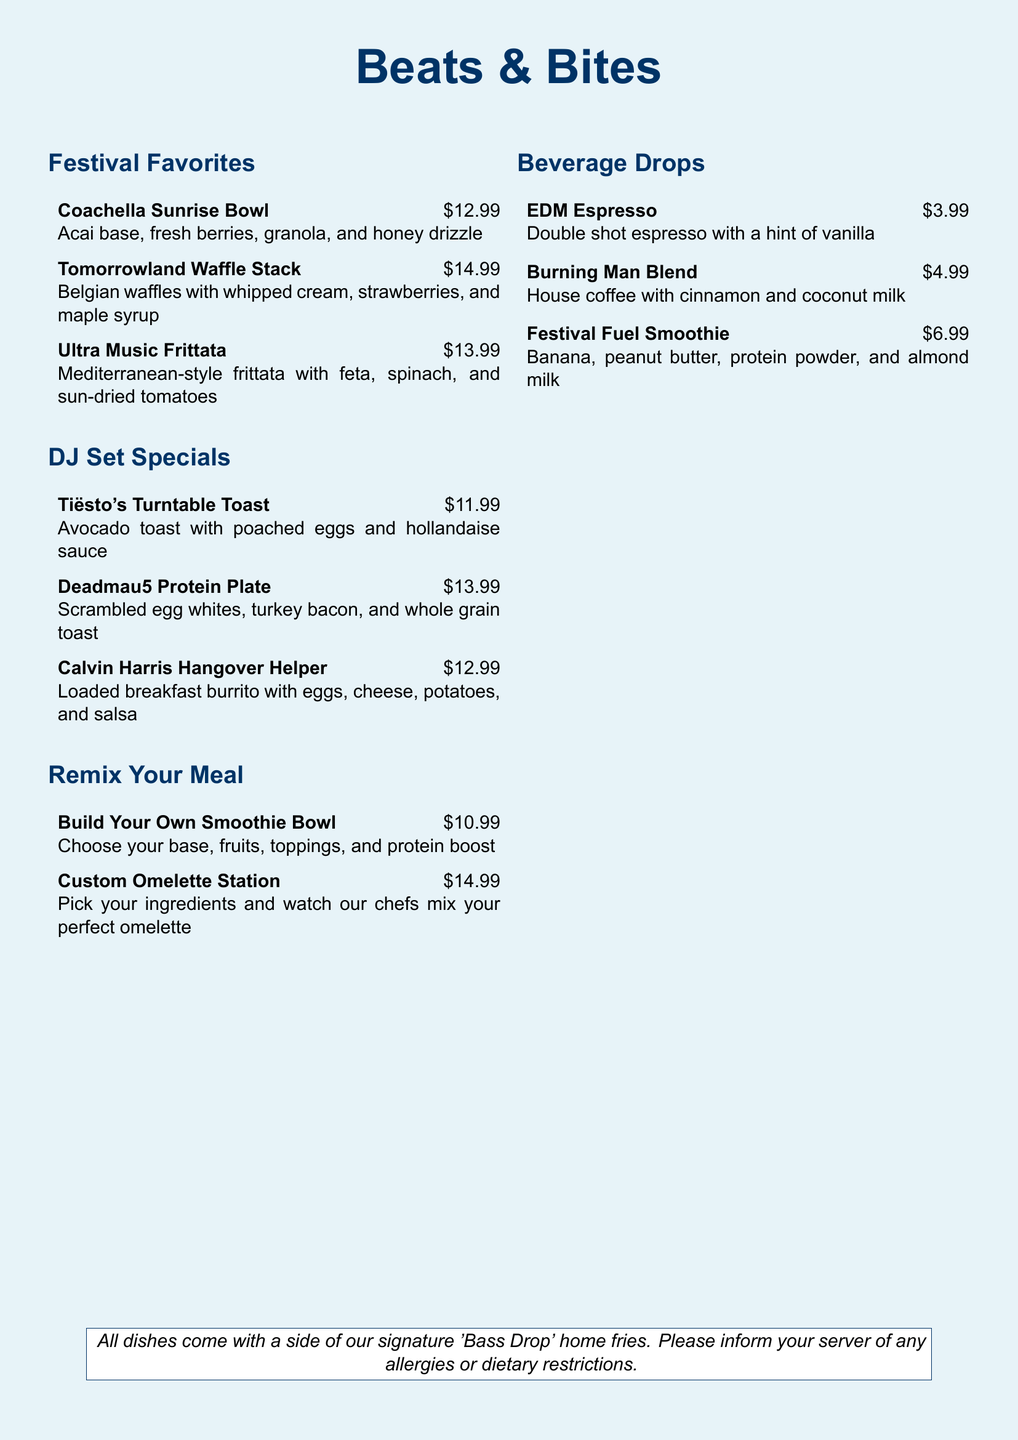What is the price of the Coachella Sunrise Bowl? The price of the Coachella Sunrise Bowl is clearly stated in the menu.
Answer: $12.99 What are the ingredients in the Tomorrowland Waffle Stack? The ingredients for the Tomorrowland Waffle Stack are listed alongside the dish name in the menu.
Answer: Belgian waffles with whipped cream, strawberries, and maple syrup How much does the Deadmau5 Protein Plate cost? The cost of the Deadmau5 Protein Plate is presented in the menu next to the dish name.
Answer: $13.99 What beverage is described as having a hint of vanilla? The description of the EDM Espresso indicates its flavor profile in the menu.
Answer: EDM Espresso What dish combines scrambled egg whites and turkey bacon? The Deadmau5 Protein Plate includes these specific ingredients and is named in the menu.
Answer: Deadmau5 Protein Plate How many categories of dishes are in the menu? The document outlines different sections, indicating the number of categories present.
Answer: Three 